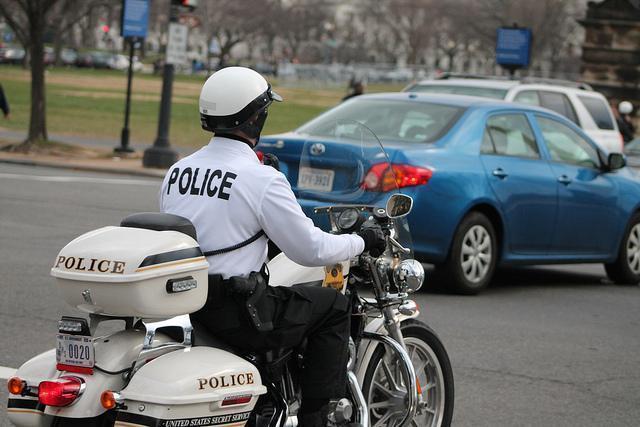The Harley police bikes are iconic bikes of police force in?
Choose the right answer from the provided options to respond to the question.
Options: Uk, australia, france, us. Us. 